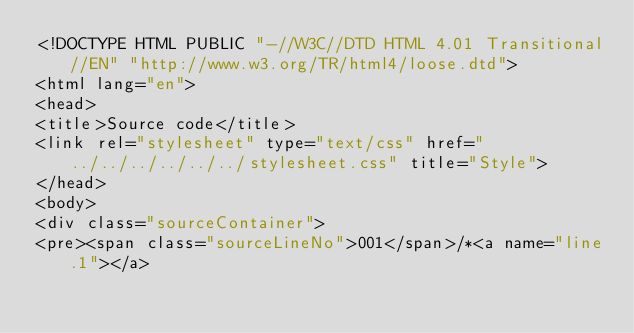Convert code to text. <code><loc_0><loc_0><loc_500><loc_500><_HTML_><!DOCTYPE HTML PUBLIC "-//W3C//DTD HTML 4.01 Transitional//EN" "http://www.w3.org/TR/html4/loose.dtd">
<html lang="en">
<head>
<title>Source code</title>
<link rel="stylesheet" type="text/css" href="../../../../../../stylesheet.css" title="Style">
</head>
<body>
<div class="sourceContainer">
<pre><span class="sourceLineNo">001</span>/*<a name="line.1"></a></code> 